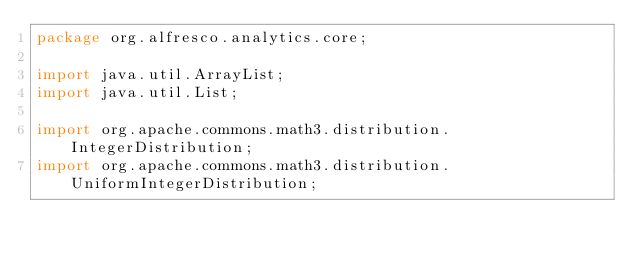<code> <loc_0><loc_0><loc_500><loc_500><_Java_>package org.alfresco.analytics.core;

import java.util.ArrayList;
import java.util.List;

import org.apache.commons.math3.distribution.IntegerDistribution;
import org.apache.commons.math3.distribution.UniformIntegerDistribution;</code> 